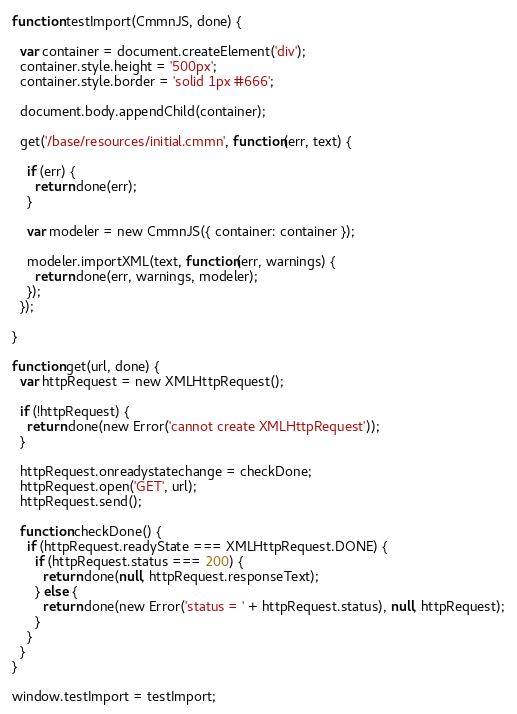<code> <loc_0><loc_0><loc_500><loc_500><_JavaScript_>
function testImport(CmmnJS, done) {

  var container = document.createElement('div');
  container.style.height = '500px';
  container.style.border = 'solid 1px #666';

  document.body.appendChild(container);

  get('/base/resources/initial.cmmn', function(err, text) {

    if (err) {
      return done(err);
    }

    var modeler = new CmmnJS({ container: container });

    modeler.importXML(text, function(err, warnings) {
      return done(err, warnings, modeler);
    });
  });

}

function get(url, done) {
  var httpRequest = new XMLHttpRequest();

  if (!httpRequest) {
    return done(new Error('cannot create XMLHttpRequest'));
  }

  httpRequest.onreadystatechange = checkDone;
  httpRequest.open('GET', url);
  httpRequest.send();

  function checkDone() {
    if (httpRequest.readyState === XMLHttpRequest.DONE) {
      if (httpRequest.status === 200) {
        return done(null, httpRequest.responseText);
      } else {
        return done(new Error('status = ' + httpRequest.status), null, httpRequest);
      }
    }
  }
}

window.testImport = testImport;</code> 